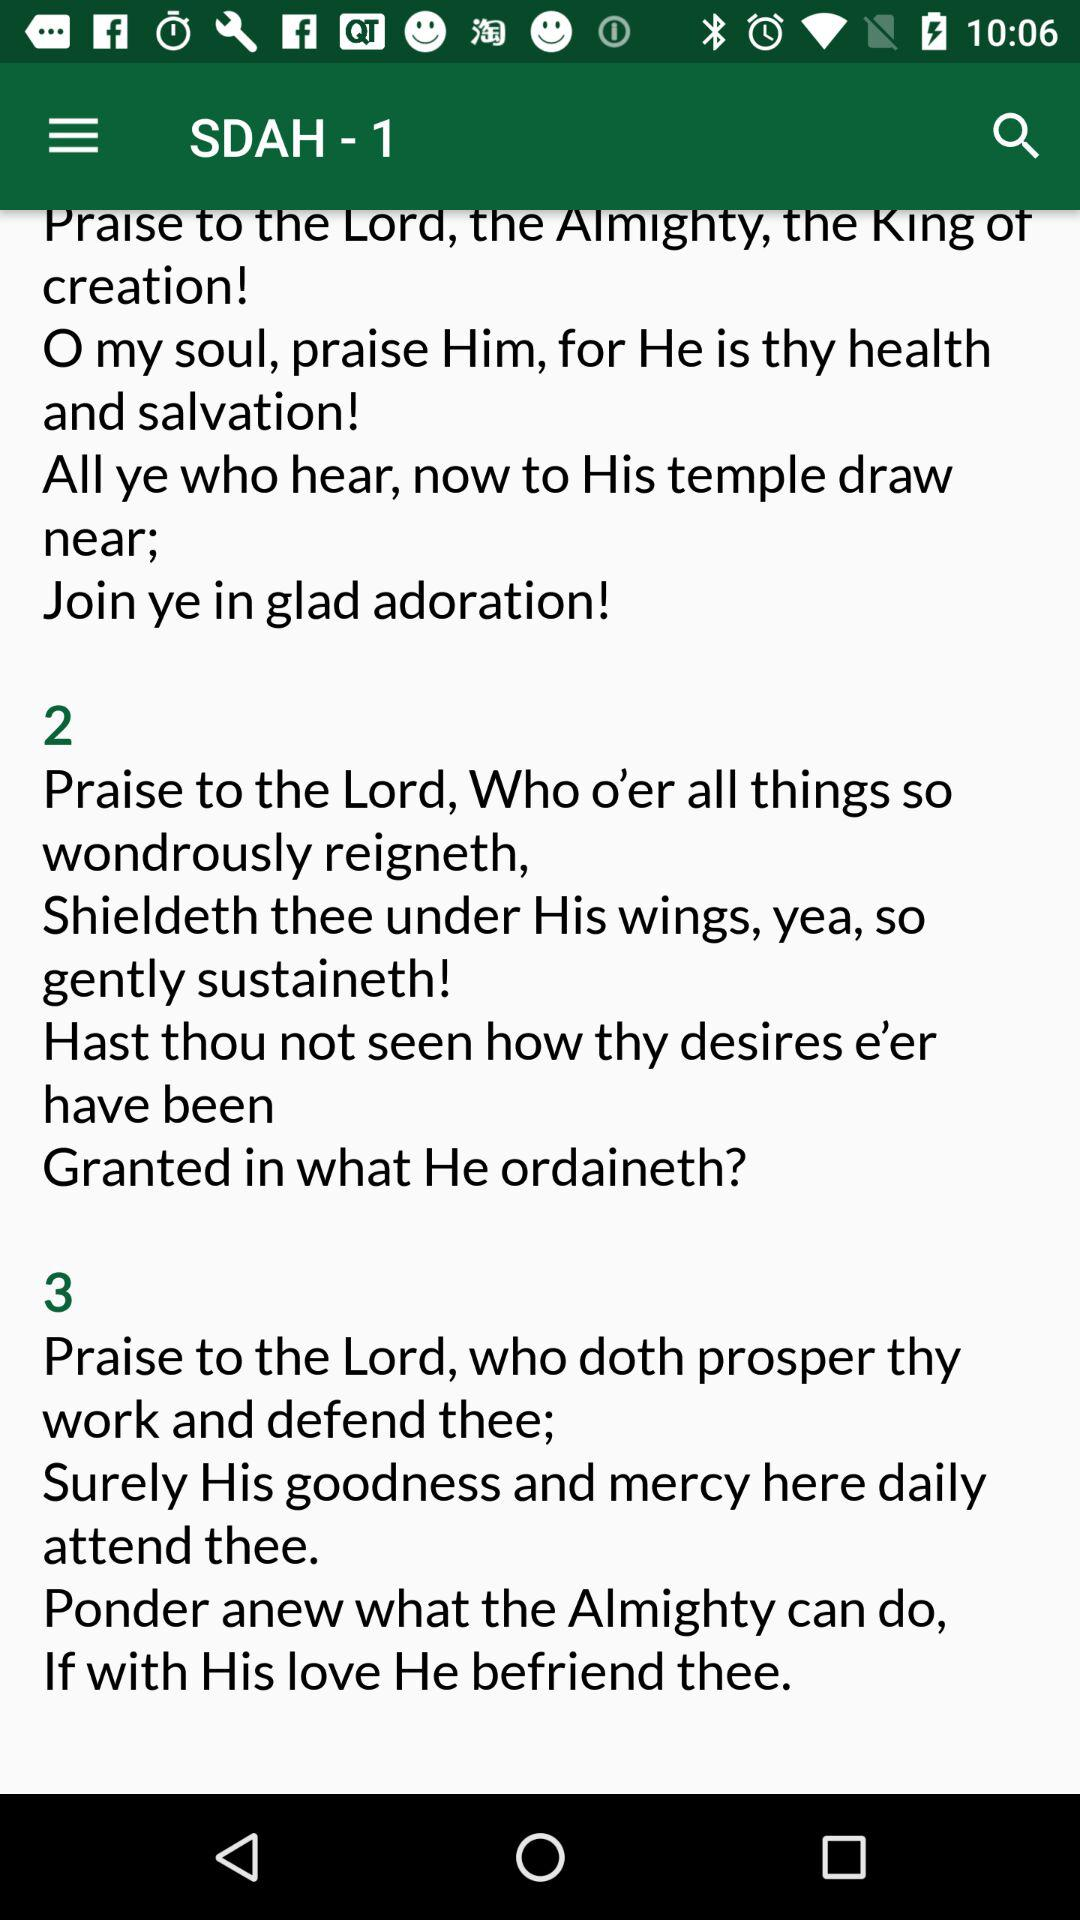How many verses are in the hymn?
Answer the question using a single word or phrase. 3 